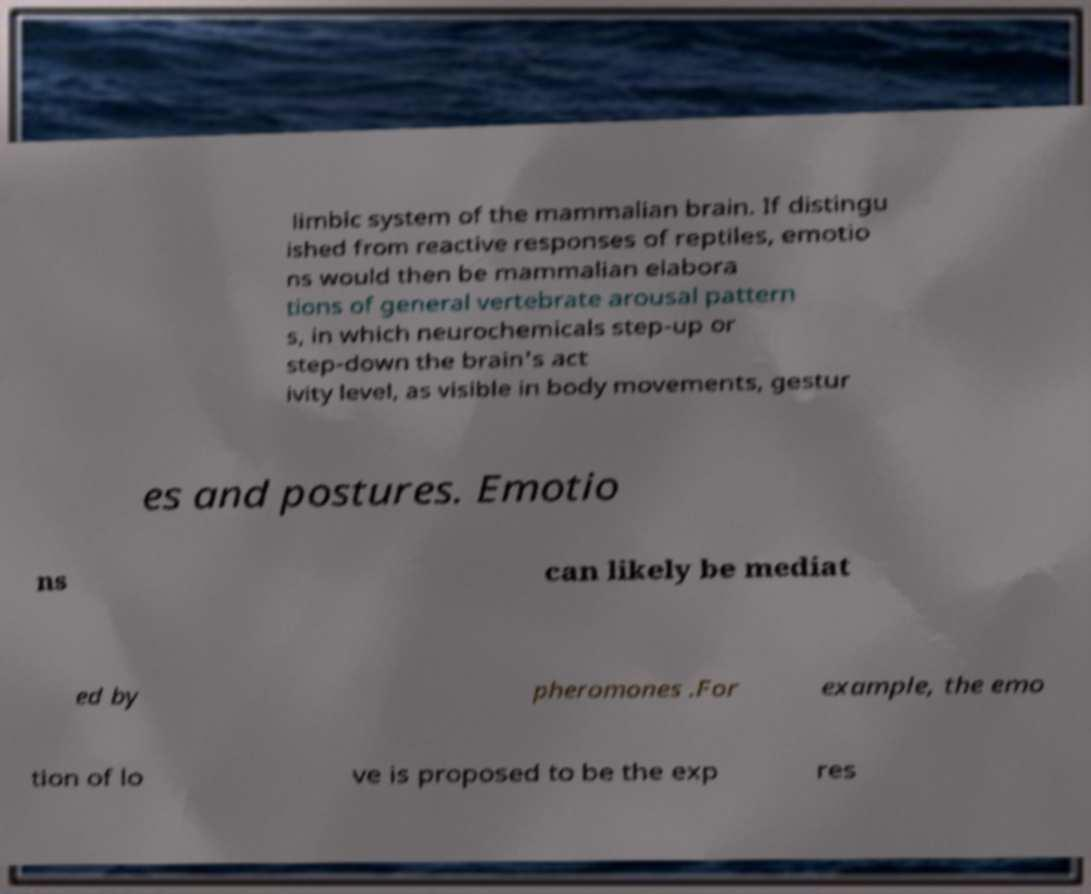I need the written content from this picture converted into text. Can you do that? limbic system of the mammalian brain. If distingu ished from reactive responses of reptiles, emotio ns would then be mammalian elabora tions of general vertebrate arousal pattern s, in which neurochemicals step-up or step-down the brain's act ivity level, as visible in body movements, gestur es and postures. Emotio ns can likely be mediat ed by pheromones .For example, the emo tion of lo ve is proposed to be the exp res 